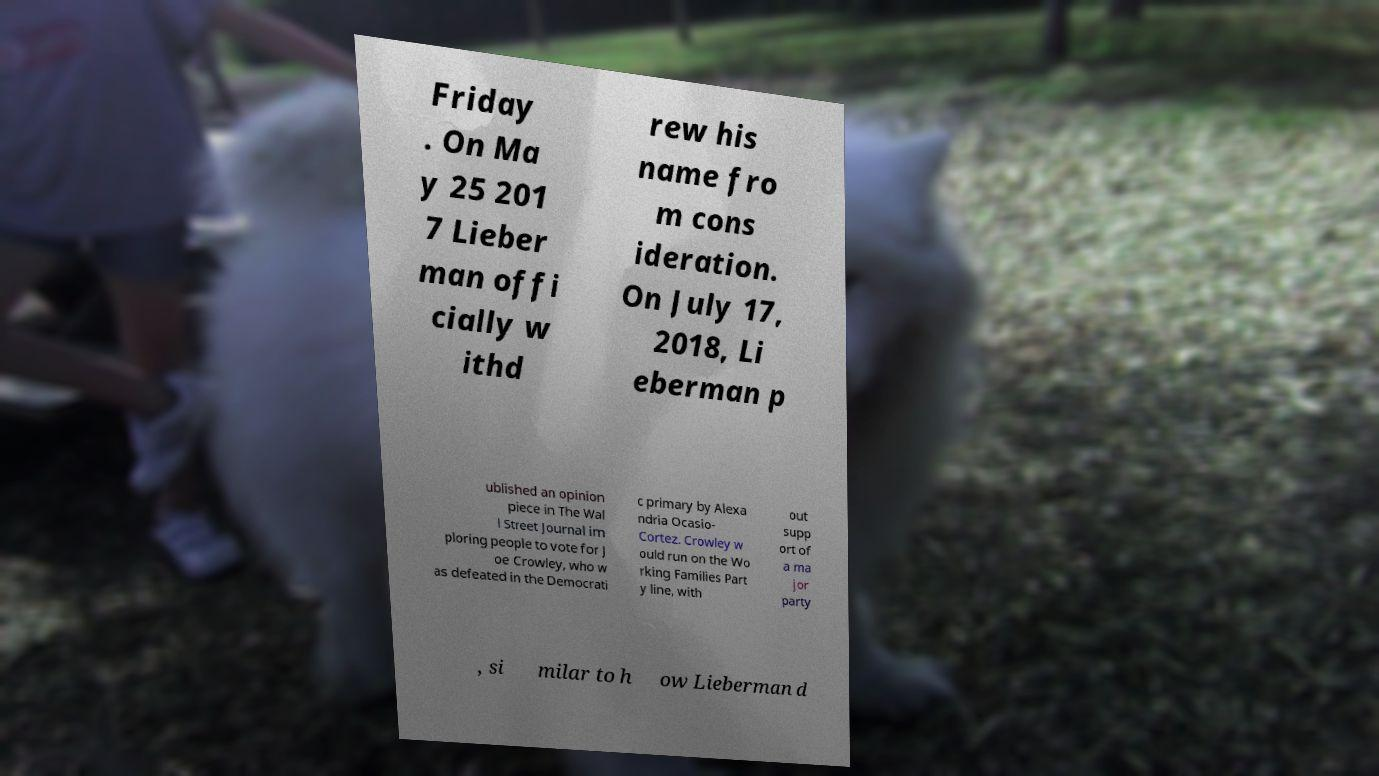For documentation purposes, I need the text within this image transcribed. Could you provide that? Friday . On Ma y 25 201 7 Lieber man offi cially w ithd rew his name fro m cons ideration. On July 17, 2018, Li eberman p ublished an opinion piece in The Wal l Street Journal im ploring people to vote for J oe Crowley, who w as defeated in the Democrati c primary by Alexa ndria Ocasio- Cortez. Crowley w ould run on the Wo rking Families Part y line, with out supp ort of a ma jor party , si milar to h ow Lieberman d 